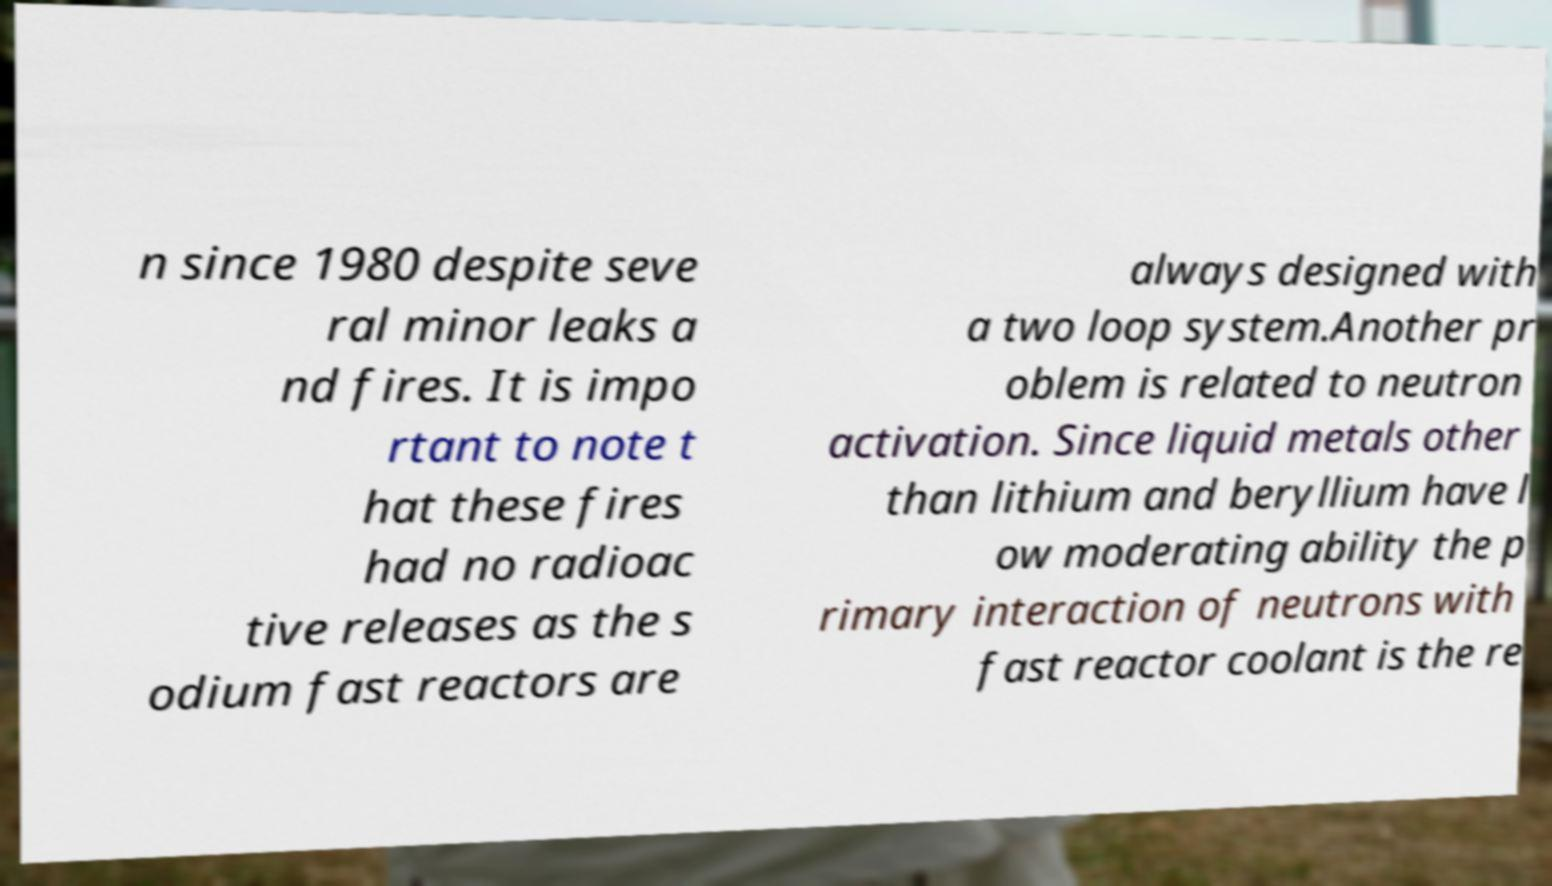Could you assist in decoding the text presented in this image and type it out clearly? n since 1980 despite seve ral minor leaks a nd fires. It is impo rtant to note t hat these fires had no radioac tive releases as the s odium fast reactors are always designed with a two loop system.Another pr oblem is related to neutron activation. Since liquid metals other than lithium and beryllium have l ow moderating ability the p rimary interaction of neutrons with fast reactor coolant is the re 